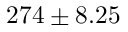<formula> <loc_0><loc_0><loc_500><loc_500>2 7 4 \pm 8 . 2 5</formula> 